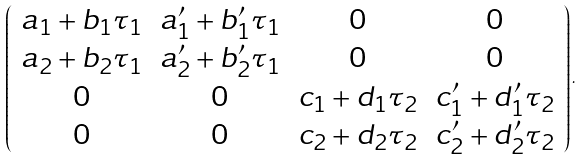<formula> <loc_0><loc_0><loc_500><loc_500>\left ( \begin{array} { c c c c } a _ { 1 } + b _ { 1 } \tau _ { 1 } & a ^ { \prime } _ { 1 } + b ^ { \prime } _ { 1 } \tau _ { 1 } & 0 & 0 \\ a _ { 2 } + b _ { 2 } \tau _ { 1 } & a ^ { \prime } _ { 2 } + b ^ { \prime } _ { 2 } \tau _ { 1 } & 0 & 0 \\ 0 & 0 & c _ { 1 } + d _ { 1 } \tau _ { 2 } & c ^ { \prime } _ { 1 } + d ^ { \prime } _ { 1 } \tau _ { 2 } \\ 0 & 0 & c _ { 2 } + d _ { 2 } \tau _ { 2 } & c ^ { \prime } _ { 2 } + d ^ { \prime } _ { 2 } \tau _ { 2 } \end{array} \right ) .</formula> 